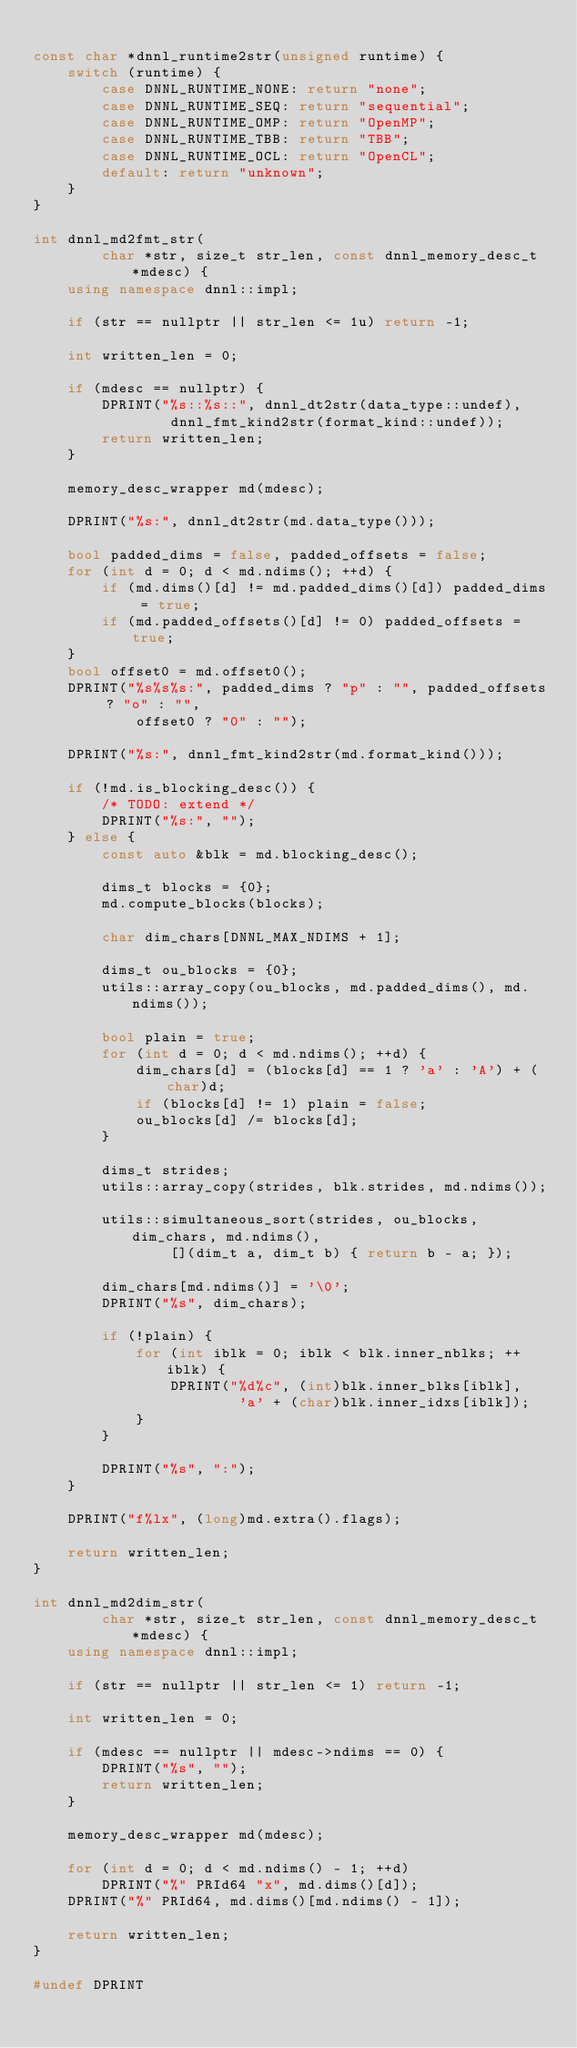<code> <loc_0><loc_0><loc_500><loc_500><_C++_>
const char *dnnl_runtime2str(unsigned runtime) {
    switch (runtime) {
        case DNNL_RUNTIME_NONE: return "none";
        case DNNL_RUNTIME_SEQ: return "sequential";
        case DNNL_RUNTIME_OMP: return "OpenMP";
        case DNNL_RUNTIME_TBB: return "TBB";
        case DNNL_RUNTIME_OCL: return "OpenCL";
        default: return "unknown";
    }
}

int dnnl_md2fmt_str(
        char *str, size_t str_len, const dnnl_memory_desc_t *mdesc) {
    using namespace dnnl::impl;

    if (str == nullptr || str_len <= 1u) return -1;

    int written_len = 0;

    if (mdesc == nullptr) {
        DPRINT("%s::%s::", dnnl_dt2str(data_type::undef),
                dnnl_fmt_kind2str(format_kind::undef));
        return written_len;
    }

    memory_desc_wrapper md(mdesc);

    DPRINT("%s:", dnnl_dt2str(md.data_type()));

    bool padded_dims = false, padded_offsets = false;
    for (int d = 0; d < md.ndims(); ++d) {
        if (md.dims()[d] != md.padded_dims()[d]) padded_dims = true;
        if (md.padded_offsets()[d] != 0) padded_offsets = true;
    }
    bool offset0 = md.offset0();
    DPRINT("%s%s%s:", padded_dims ? "p" : "", padded_offsets ? "o" : "",
            offset0 ? "0" : "");

    DPRINT("%s:", dnnl_fmt_kind2str(md.format_kind()));

    if (!md.is_blocking_desc()) {
        /* TODO: extend */
        DPRINT("%s:", "");
    } else {
        const auto &blk = md.blocking_desc();

        dims_t blocks = {0};
        md.compute_blocks(blocks);

        char dim_chars[DNNL_MAX_NDIMS + 1];

        dims_t ou_blocks = {0};
        utils::array_copy(ou_blocks, md.padded_dims(), md.ndims());

        bool plain = true;
        for (int d = 0; d < md.ndims(); ++d) {
            dim_chars[d] = (blocks[d] == 1 ? 'a' : 'A') + (char)d;
            if (blocks[d] != 1) plain = false;
            ou_blocks[d] /= blocks[d];
        }

        dims_t strides;
        utils::array_copy(strides, blk.strides, md.ndims());

        utils::simultaneous_sort(strides, ou_blocks, dim_chars, md.ndims(),
                [](dim_t a, dim_t b) { return b - a; });

        dim_chars[md.ndims()] = '\0';
        DPRINT("%s", dim_chars);

        if (!plain) {
            for (int iblk = 0; iblk < blk.inner_nblks; ++iblk) {
                DPRINT("%d%c", (int)blk.inner_blks[iblk],
                        'a' + (char)blk.inner_idxs[iblk]);
            }
        }

        DPRINT("%s", ":");
    }

    DPRINT("f%lx", (long)md.extra().flags);

    return written_len;
}

int dnnl_md2dim_str(
        char *str, size_t str_len, const dnnl_memory_desc_t *mdesc) {
    using namespace dnnl::impl;

    if (str == nullptr || str_len <= 1) return -1;

    int written_len = 0;

    if (mdesc == nullptr || mdesc->ndims == 0) {
        DPRINT("%s", "");
        return written_len;
    }

    memory_desc_wrapper md(mdesc);

    for (int d = 0; d < md.ndims() - 1; ++d)
        DPRINT("%" PRId64 "x", md.dims()[d]);
    DPRINT("%" PRId64, md.dims()[md.ndims() - 1]);

    return written_len;
}

#undef DPRINT
</code> 